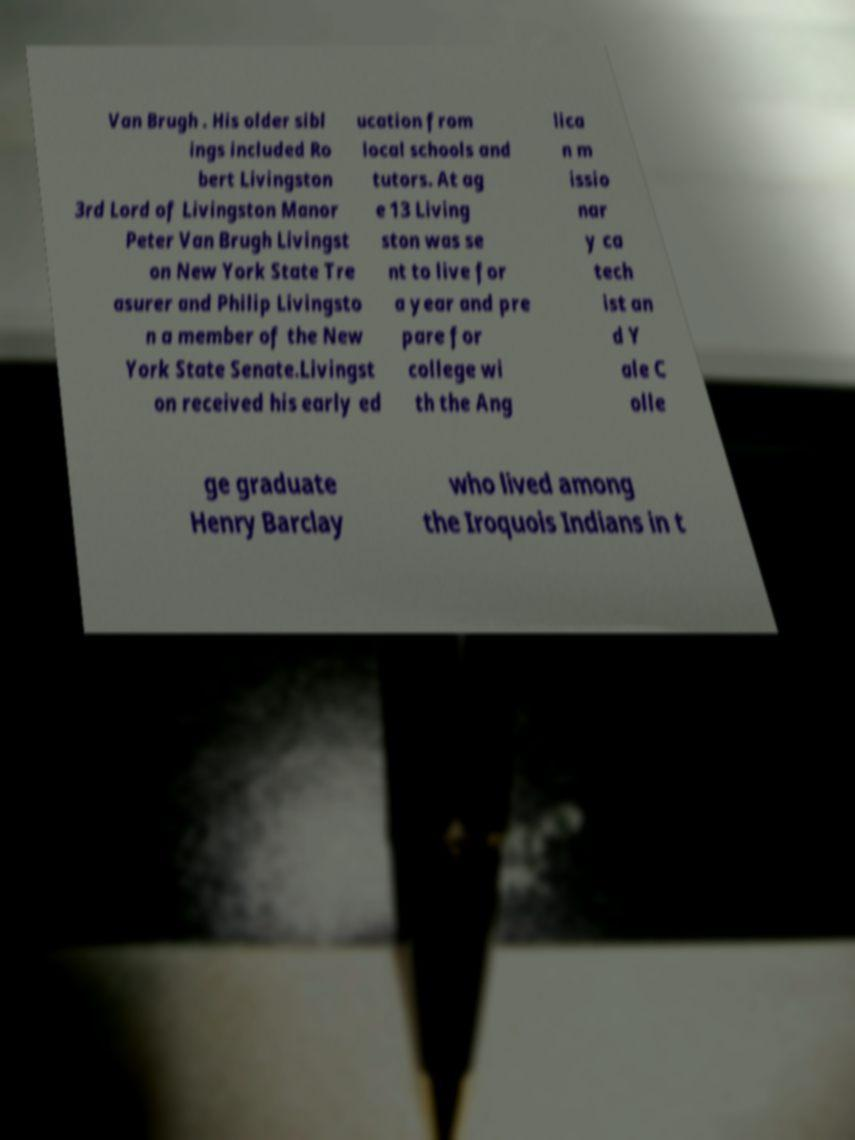Please read and relay the text visible in this image. What does it say? Van Brugh . His older sibl ings included Ro bert Livingston 3rd Lord of Livingston Manor Peter Van Brugh Livingst on New York State Tre asurer and Philip Livingsto n a member of the New York State Senate.Livingst on received his early ed ucation from local schools and tutors. At ag e 13 Living ston was se nt to live for a year and pre pare for college wi th the Ang lica n m issio nar y ca tech ist an d Y ale C olle ge graduate Henry Barclay who lived among the Iroquois Indians in t 